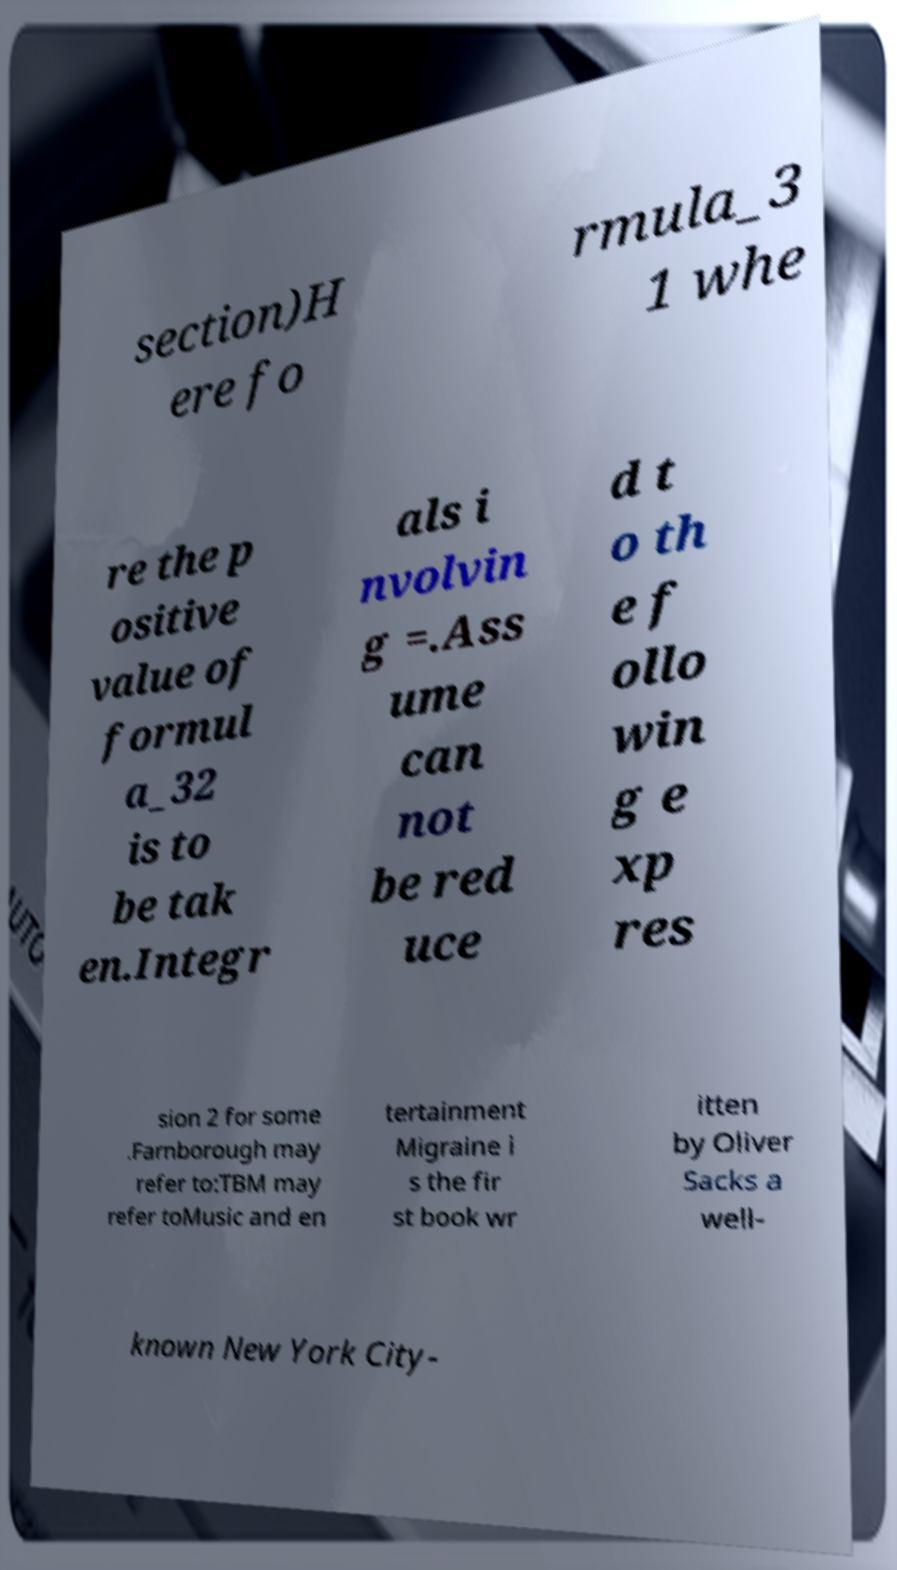Could you assist in decoding the text presented in this image and type it out clearly? section)H ere fo rmula_3 1 whe re the p ositive value of formul a_32 is to be tak en.Integr als i nvolvin g =.Ass ume can not be red uce d t o th e f ollo win g e xp res sion 2 for some .Farnborough may refer to:TBM may refer toMusic and en tertainment Migraine i s the fir st book wr itten by Oliver Sacks a well- known New York City- 